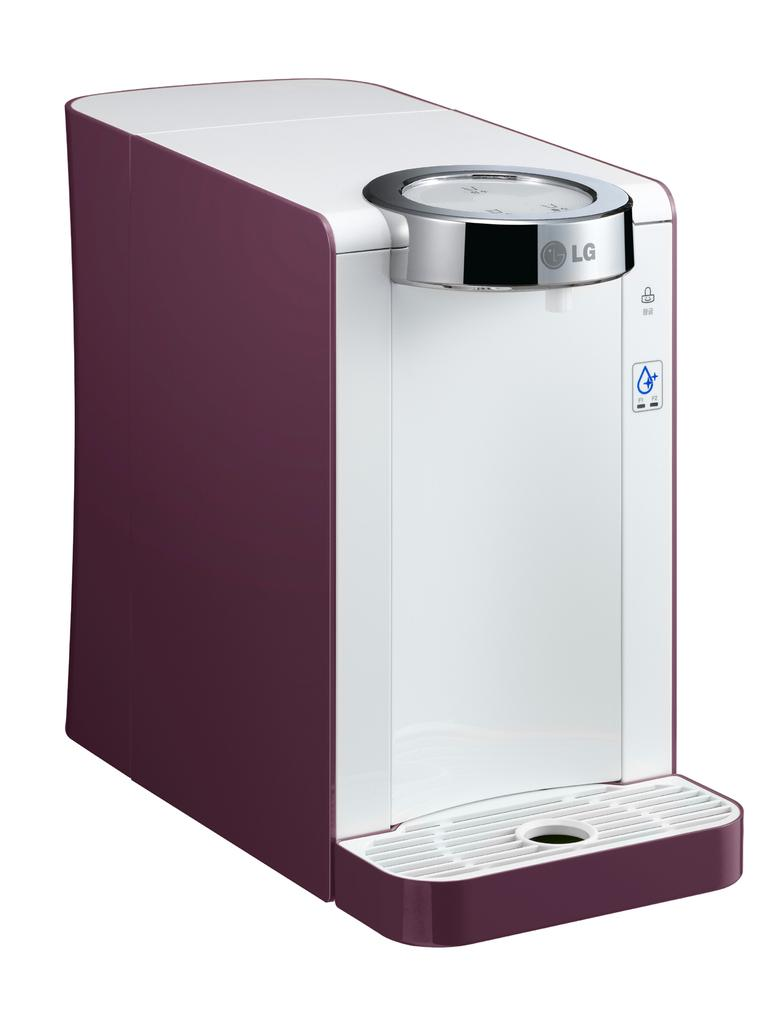<image>
Write a terse but informative summary of the picture. LG is the brand name shown on the top of this appliance. 